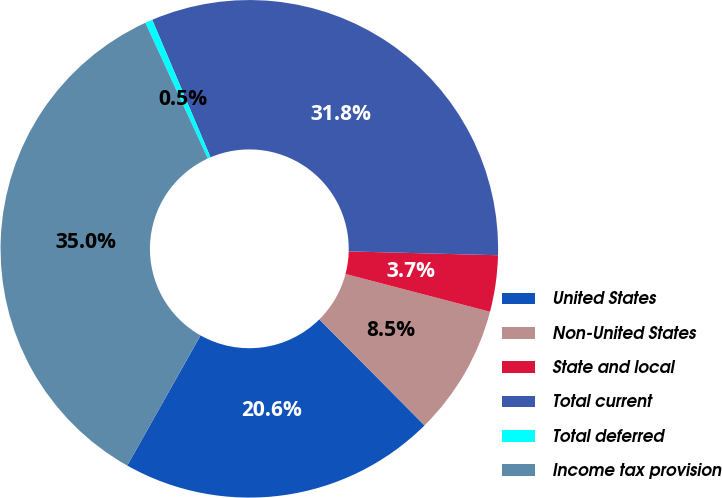<chart> <loc_0><loc_0><loc_500><loc_500><pie_chart><fcel>United States<fcel>Non-United States<fcel>State and local<fcel>Total current<fcel>Total deferred<fcel>Income tax provision<nl><fcel>20.6%<fcel>8.49%<fcel>3.66%<fcel>31.79%<fcel>0.48%<fcel>34.97%<nl></chart> 